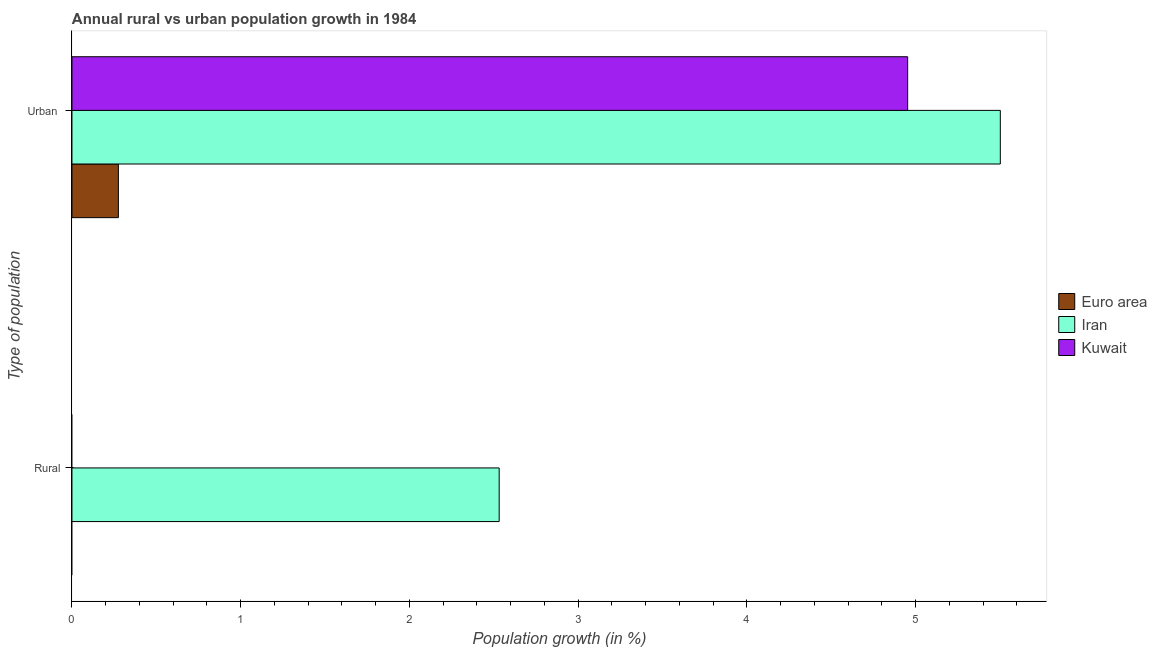Are the number of bars per tick equal to the number of legend labels?
Your answer should be compact. No. Are the number of bars on each tick of the Y-axis equal?
Your answer should be very brief. No. What is the label of the 1st group of bars from the top?
Provide a succinct answer. Urban . Across all countries, what is the maximum rural population growth?
Offer a terse response. 2.53. In which country was the urban population growth maximum?
Offer a very short reply. Iran. What is the total rural population growth in the graph?
Your answer should be very brief. 2.53. What is the difference between the urban population growth in Kuwait and that in Euro area?
Offer a very short reply. 4.68. What is the difference between the rural population growth in Iran and the urban population growth in Kuwait?
Your answer should be very brief. -2.42. What is the average urban population growth per country?
Ensure brevity in your answer.  3.58. What is the difference between the urban population growth and rural population growth in Iran?
Keep it short and to the point. 2.97. What is the ratio of the urban population growth in Iran to that in Euro area?
Give a very brief answer. 20. Is the urban population growth in Iran less than that in Kuwait?
Your answer should be very brief. No. Are all the bars in the graph horizontal?
Give a very brief answer. Yes. How many countries are there in the graph?
Give a very brief answer. 3. What is the difference between two consecutive major ticks on the X-axis?
Your answer should be very brief. 1. Are the values on the major ticks of X-axis written in scientific E-notation?
Offer a very short reply. No. Does the graph contain grids?
Ensure brevity in your answer.  No. Where does the legend appear in the graph?
Your response must be concise. Center right. How are the legend labels stacked?
Give a very brief answer. Vertical. What is the title of the graph?
Offer a terse response. Annual rural vs urban population growth in 1984. What is the label or title of the X-axis?
Your response must be concise. Population growth (in %). What is the label or title of the Y-axis?
Your answer should be very brief. Type of population. What is the Population growth (in %) of Euro area in Rural?
Give a very brief answer. 0. What is the Population growth (in %) in Iran in Rural?
Your answer should be compact. 2.53. What is the Population growth (in %) in Kuwait in Rural?
Offer a terse response. 0. What is the Population growth (in %) of Euro area in Urban ?
Give a very brief answer. 0.28. What is the Population growth (in %) of Iran in Urban ?
Ensure brevity in your answer.  5.5. What is the Population growth (in %) of Kuwait in Urban ?
Your answer should be very brief. 4.95. Across all Type of population, what is the maximum Population growth (in %) in Euro area?
Make the answer very short. 0.28. Across all Type of population, what is the maximum Population growth (in %) of Iran?
Provide a succinct answer. 5.5. Across all Type of population, what is the maximum Population growth (in %) in Kuwait?
Your response must be concise. 4.95. Across all Type of population, what is the minimum Population growth (in %) of Iran?
Provide a succinct answer. 2.53. What is the total Population growth (in %) in Euro area in the graph?
Offer a terse response. 0.28. What is the total Population growth (in %) of Iran in the graph?
Keep it short and to the point. 8.03. What is the total Population growth (in %) in Kuwait in the graph?
Your answer should be compact. 4.95. What is the difference between the Population growth (in %) in Iran in Rural and that in Urban ?
Provide a succinct answer. -2.97. What is the difference between the Population growth (in %) in Iran in Rural and the Population growth (in %) in Kuwait in Urban ?
Keep it short and to the point. -2.42. What is the average Population growth (in %) in Euro area per Type of population?
Your answer should be very brief. 0.14. What is the average Population growth (in %) of Iran per Type of population?
Your response must be concise. 4.02. What is the average Population growth (in %) in Kuwait per Type of population?
Offer a terse response. 2.48. What is the difference between the Population growth (in %) in Euro area and Population growth (in %) in Iran in Urban ?
Make the answer very short. -5.23. What is the difference between the Population growth (in %) in Euro area and Population growth (in %) in Kuwait in Urban ?
Give a very brief answer. -4.68. What is the difference between the Population growth (in %) in Iran and Population growth (in %) in Kuwait in Urban ?
Offer a terse response. 0.55. What is the ratio of the Population growth (in %) in Iran in Rural to that in Urban ?
Your response must be concise. 0.46. What is the difference between the highest and the second highest Population growth (in %) in Iran?
Offer a very short reply. 2.97. What is the difference between the highest and the lowest Population growth (in %) of Euro area?
Offer a terse response. 0.28. What is the difference between the highest and the lowest Population growth (in %) in Iran?
Ensure brevity in your answer.  2.97. What is the difference between the highest and the lowest Population growth (in %) of Kuwait?
Keep it short and to the point. 4.95. 